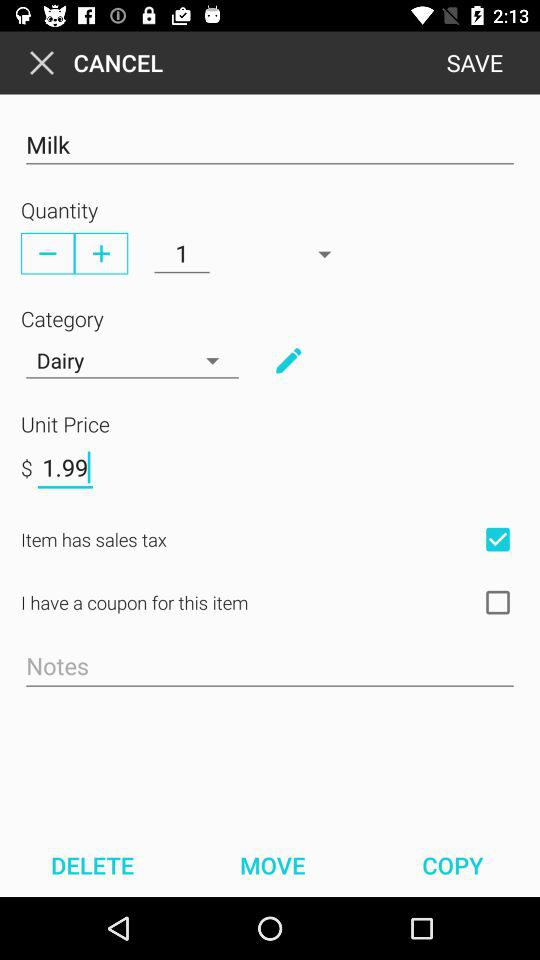What is the product? The product is "Milk". 